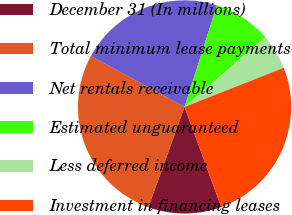Convert chart to OTSL. <chart><loc_0><loc_0><loc_500><loc_500><pie_chart><fcel>December 31 (In millions)<fcel>Total minimum lease payments<fcel>Net rentals receivable<fcel>Estimated unguaranteed<fcel>Less deferred income<fcel>Investment in financing leases<nl><fcel>11.1%<fcel>27.4%<fcel>22.0%<fcel>8.75%<fcel>5.36%<fcel>25.39%<nl></chart> 